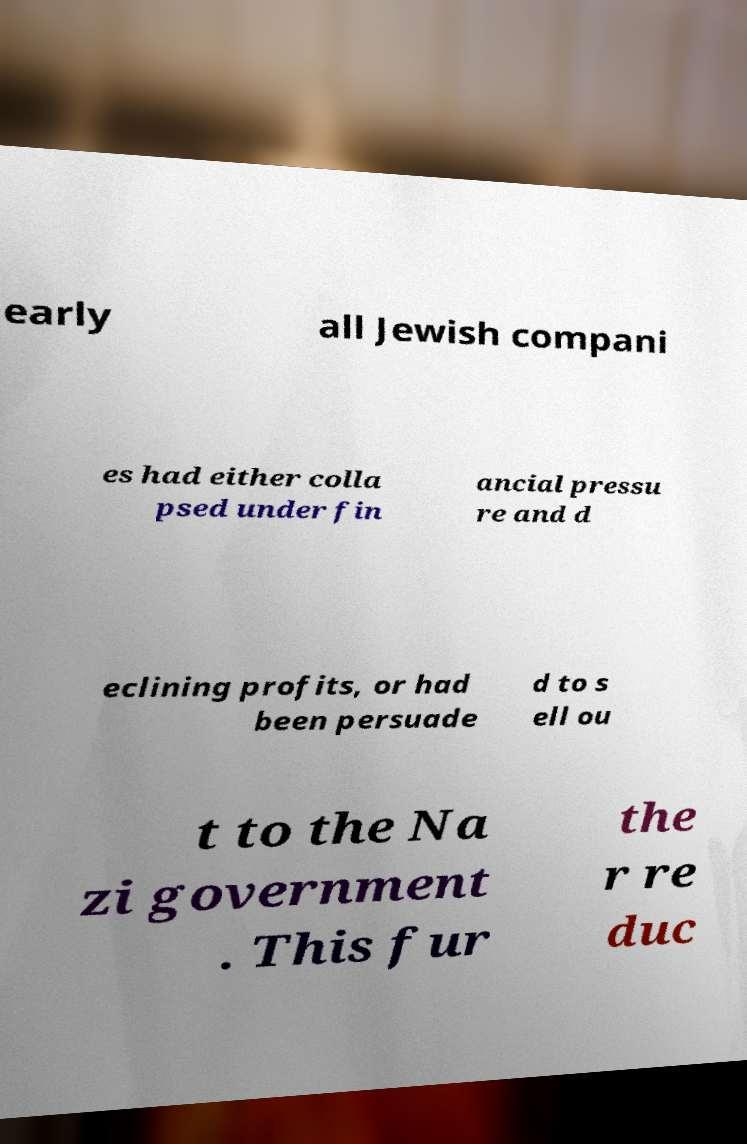I need the written content from this picture converted into text. Can you do that? early all Jewish compani es had either colla psed under fin ancial pressu re and d eclining profits, or had been persuade d to s ell ou t to the Na zi government . This fur the r re duc 